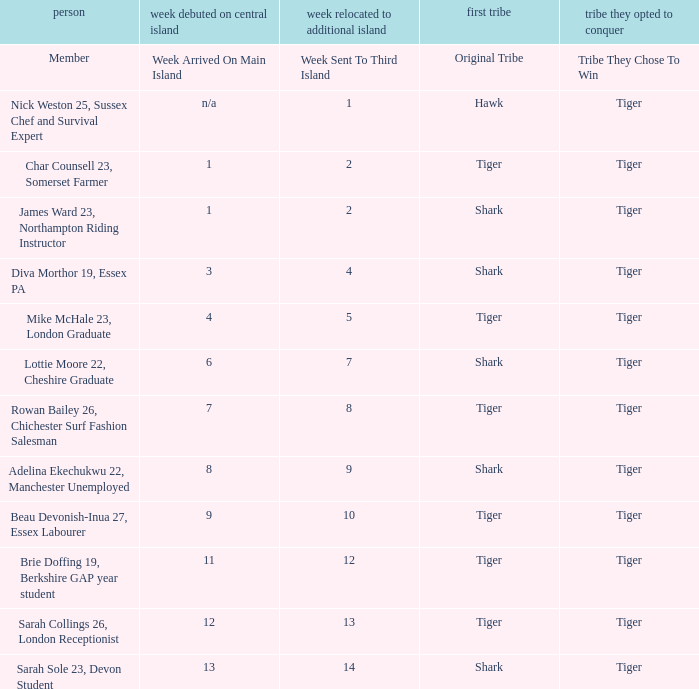How many members arrived on the main island in week 4? 1.0. 